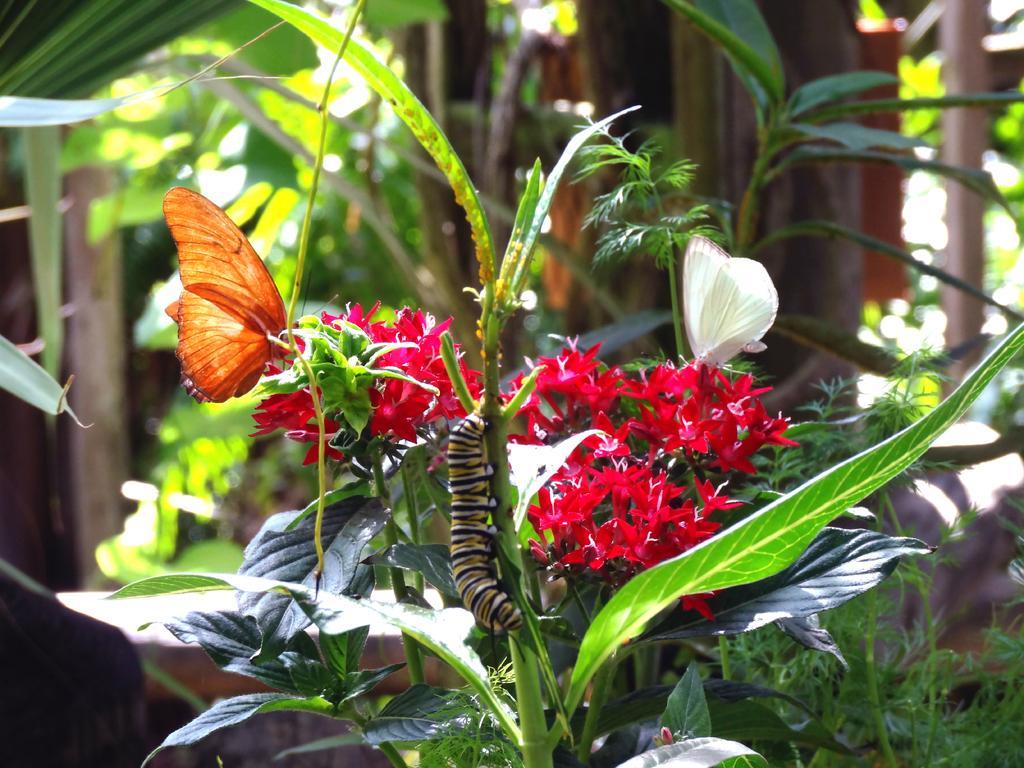Please provide a concise description of this image. In this image there is a caterpillar on the plant. Two butter flies are on the flowers of a plant having few leaves. Behind it there are few plants. 